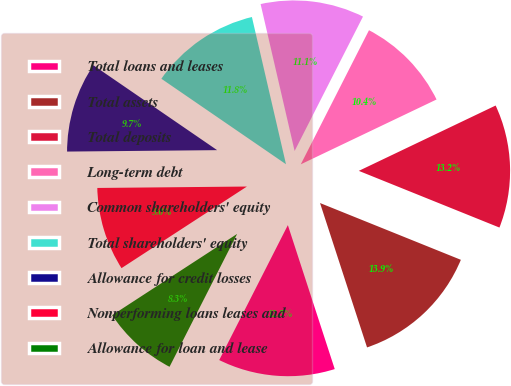Convert chart. <chart><loc_0><loc_0><loc_500><loc_500><pie_chart><fcel>Total loans and leases<fcel>Total assets<fcel>Total deposits<fcel>Long-term debt<fcel>Common shareholders' equity<fcel>Total shareholders' equity<fcel>Allowance for credit losses<fcel>Nonperforming loans leases and<fcel>Allowance for loan and lease<nl><fcel>12.5%<fcel>13.89%<fcel>13.19%<fcel>10.42%<fcel>11.11%<fcel>11.81%<fcel>9.72%<fcel>9.03%<fcel>8.33%<nl></chart> 